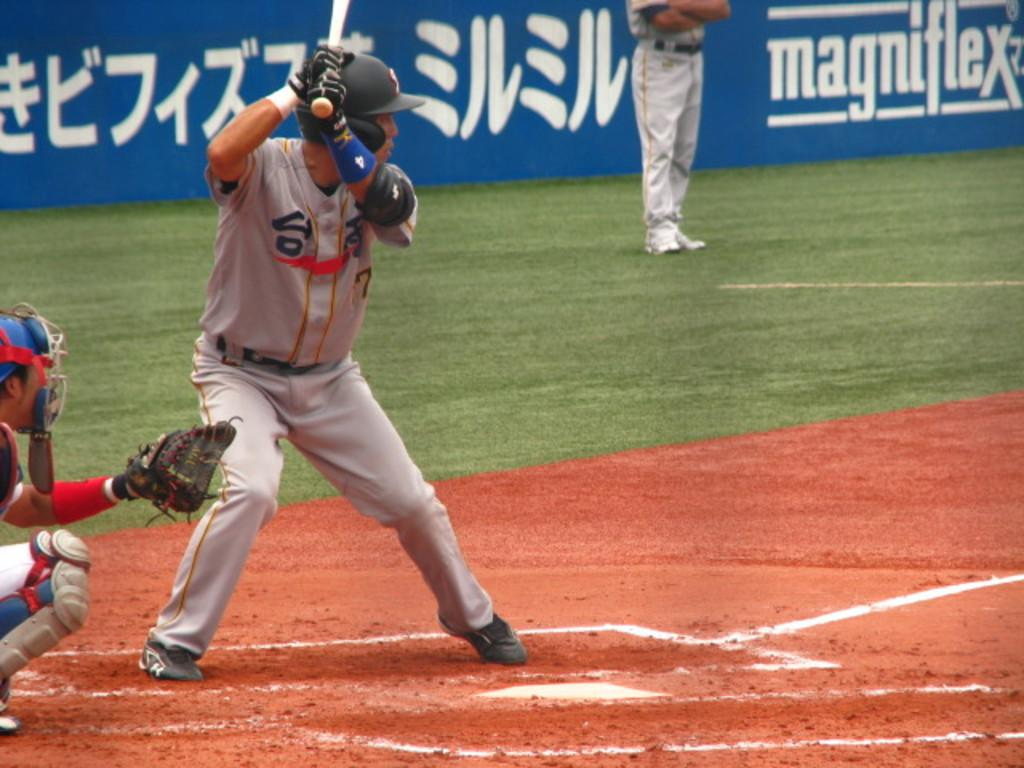<image>
Create a compact narrative representing the image presented. A batter is in position with his helmet on in front of an ad for magniflex. 